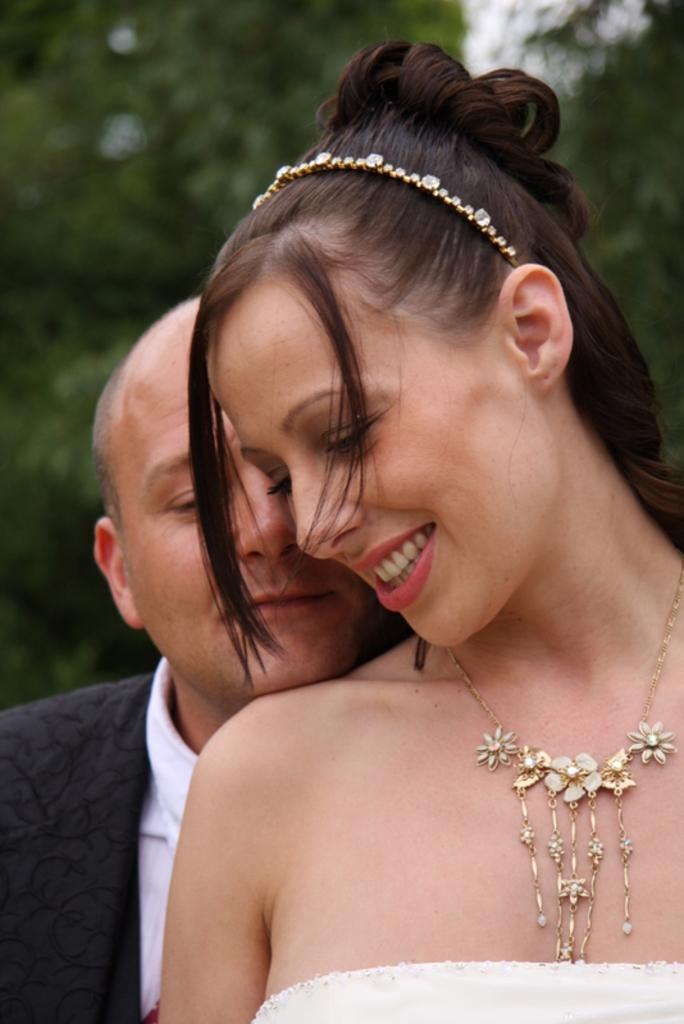How many people are in the image? There are two people in the image. Can you describe one of the people in the image? One of the people is a woman. What expression does the woman have in the image? The woman is smiling. What can be seen in the background of the image? Trees and the sky are visible in the background of the image. What is the purpose of the metal object in the image? There is no metal object present in the image. Can you describe the aftermath of the event depicted in the image? There is no event depicted in the image, so it is not possible to describe its aftermath. 